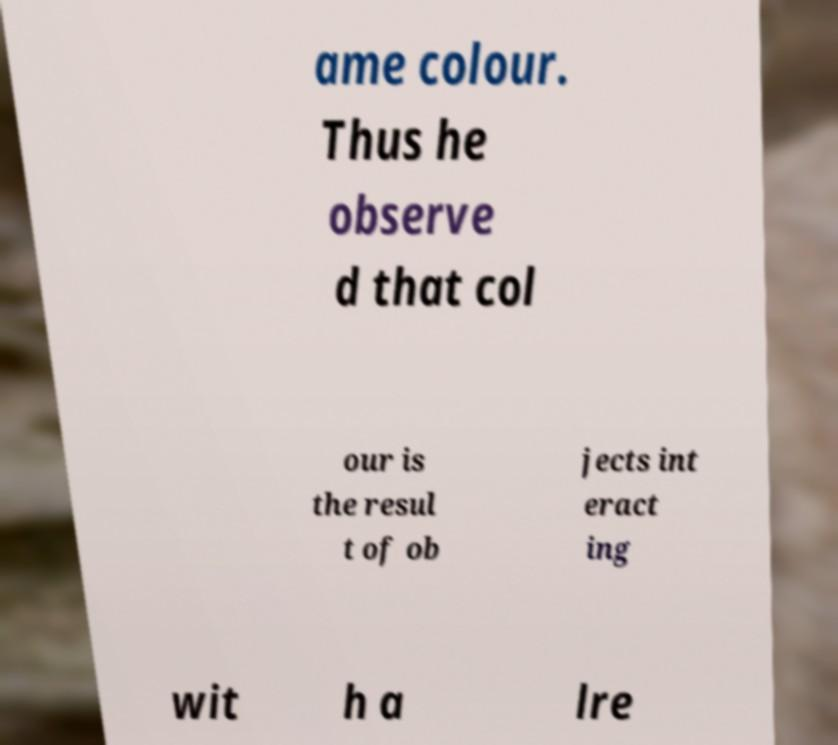Could you assist in decoding the text presented in this image and type it out clearly? ame colour. Thus he observe d that col our is the resul t of ob jects int eract ing wit h a lre 